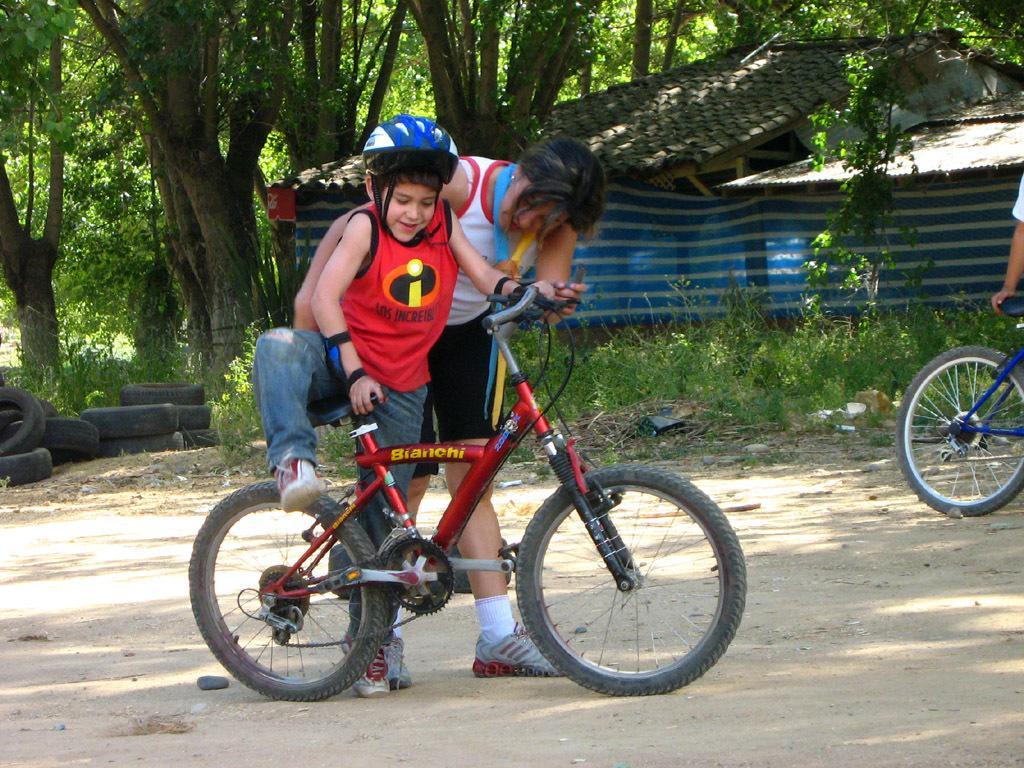Can you describe this image briefly? There is a small boy about to sit on a bicycle and a lady in the foreground area of the image, there is another person, bicycle, house and trees in the background. 